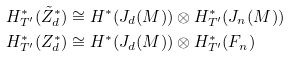Convert formula to latex. <formula><loc_0><loc_0><loc_500><loc_500>H _ { T ^ { \prime } } ^ { * } ( \tilde { Z } _ { d } ^ { * } ) & \cong H ^ { * } ( J _ { d } ( M ) ) \otimes H _ { T ^ { \prime } } ^ { * } ( J _ { n } ( M ) ) \\ H _ { T ^ { \prime } } ^ { * } ( Z _ { d } ^ { * } ) & \cong H ^ { * } ( J _ { d } ( M ) ) \otimes H _ { T ^ { \prime } } ^ { * } ( F _ { n } )</formula> 